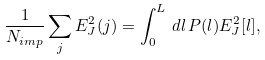<formula> <loc_0><loc_0><loc_500><loc_500>\frac { 1 } { N _ { i m p } } \sum _ { j } E _ { J } ^ { 2 } ( j ) = \int _ { 0 } ^ { L } \, d l \, P ( l ) E ^ { 2 } _ { J } [ l ] ,</formula> 